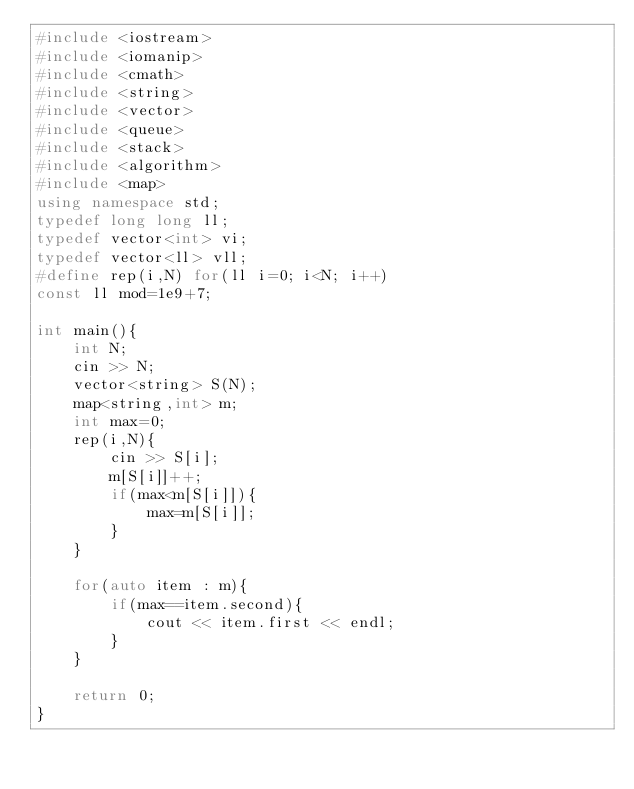Convert code to text. <code><loc_0><loc_0><loc_500><loc_500><_C++_>#include <iostream>
#include <iomanip>
#include <cmath>
#include <string>
#include <vector>
#include <queue>
#include <stack>
#include <algorithm>
#include <map>
using namespace std;
typedef long long ll;
typedef vector<int> vi;
typedef vector<ll> vll;
#define rep(i,N) for(ll i=0; i<N; i++)
const ll mod=1e9+7;

int main(){
	int N;
	cin >> N;
	vector<string> S(N);
	map<string,int> m;
	int max=0;
	rep(i,N){
		cin >> S[i];
		m[S[i]]++;
		if(max<m[S[i]]){
			max=m[S[i]];
		}
	}	

	for(auto item : m){
		if(max==item.second){
			cout << item.first << endl;
		}
	}

	return 0;
}</code> 